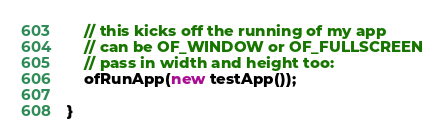<code> <loc_0><loc_0><loc_500><loc_500><_C++_>
	// this kicks off the running of my app
	// can be OF_WINDOW or OF_FULLSCREEN
	// pass in width and height too:
	ofRunApp(new testApp());

}
</code> 